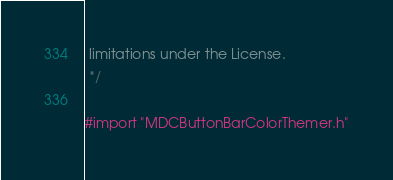Convert code to text. <code><loc_0><loc_0><loc_500><loc_500><_C_> limitations under the License.
 */

#import "MDCButtonBarColorThemer.h"
</code> 